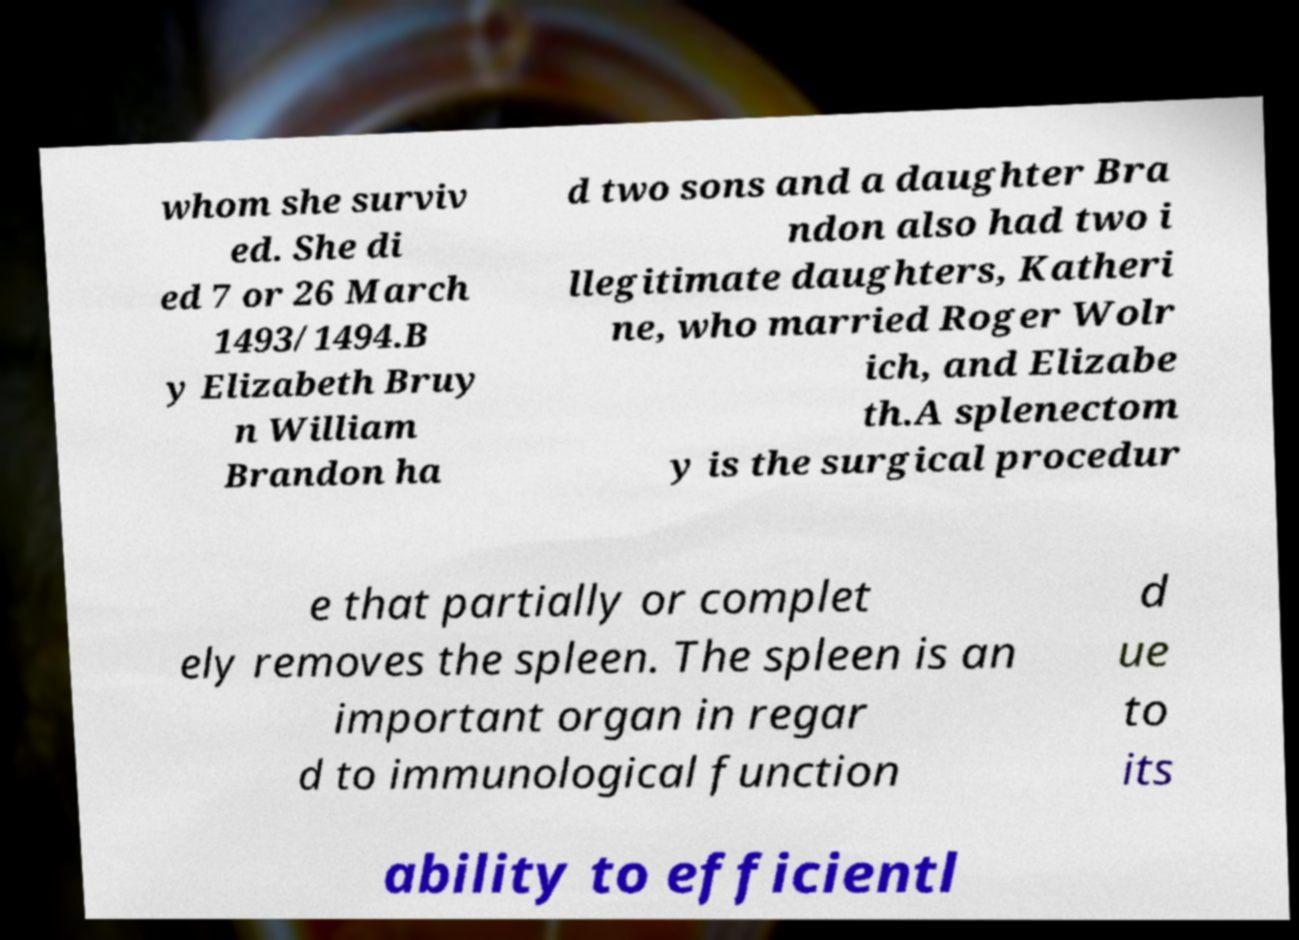There's text embedded in this image that I need extracted. Can you transcribe it verbatim? whom she surviv ed. She di ed 7 or 26 March 1493/1494.B y Elizabeth Bruy n William Brandon ha d two sons and a daughter Bra ndon also had two i llegitimate daughters, Katheri ne, who married Roger Wolr ich, and Elizabe th.A splenectom y is the surgical procedur e that partially or complet ely removes the spleen. The spleen is an important organ in regar d to immunological function d ue to its ability to efficientl 